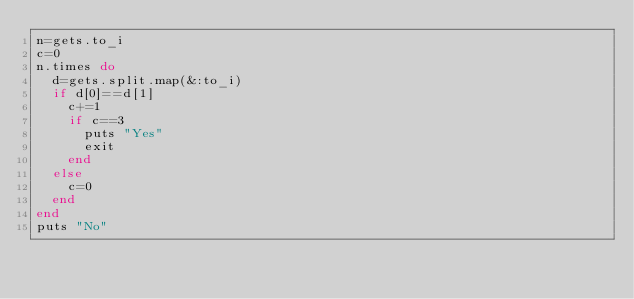Convert code to text. <code><loc_0><loc_0><loc_500><loc_500><_Ruby_>n=gets.to_i
c=0
n.times do
  d=gets.split.map(&:to_i)
  if d[0]==d[1]
    c+=1
    if c==3
      puts "Yes"
      exit
    end
  else
    c=0
  end
end
puts "No"
</code> 